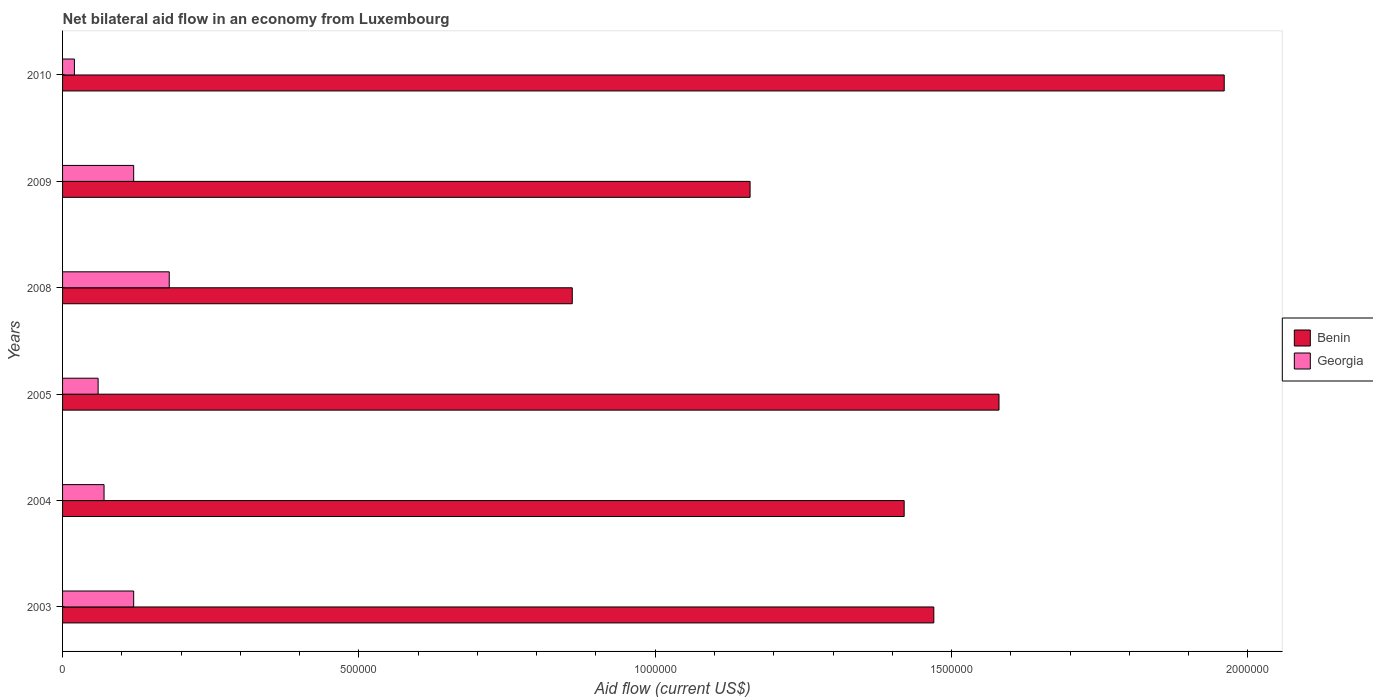Are the number of bars per tick equal to the number of legend labels?
Provide a succinct answer. Yes. How many bars are there on the 6th tick from the top?
Your response must be concise. 2. In how many cases, is the number of bars for a given year not equal to the number of legend labels?
Provide a succinct answer. 0. What is the net bilateral aid flow in Benin in 2009?
Offer a very short reply. 1.16e+06. Across all years, what is the maximum net bilateral aid flow in Benin?
Offer a terse response. 1.96e+06. Across all years, what is the minimum net bilateral aid flow in Georgia?
Ensure brevity in your answer.  2.00e+04. In which year was the net bilateral aid flow in Benin minimum?
Make the answer very short. 2008. What is the total net bilateral aid flow in Benin in the graph?
Ensure brevity in your answer.  8.45e+06. What is the difference between the net bilateral aid flow in Georgia in 2003 and that in 2009?
Give a very brief answer. 0. What is the difference between the net bilateral aid flow in Benin in 2004 and the net bilateral aid flow in Georgia in 2010?
Keep it short and to the point. 1.40e+06. What is the average net bilateral aid flow in Benin per year?
Give a very brief answer. 1.41e+06. In the year 2003, what is the difference between the net bilateral aid flow in Georgia and net bilateral aid flow in Benin?
Keep it short and to the point. -1.35e+06. In how many years, is the net bilateral aid flow in Benin greater than 1400000 US$?
Give a very brief answer. 4. Is the difference between the net bilateral aid flow in Georgia in 2004 and 2009 greater than the difference between the net bilateral aid flow in Benin in 2004 and 2009?
Give a very brief answer. No. What is the difference between the highest and the second highest net bilateral aid flow in Georgia?
Your answer should be compact. 6.00e+04. What is the difference between the highest and the lowest net bilateral aid flow in Georgia?
Offer a terse response. 1.60e+05. In how many years, is the net bilateral aid flow in Benin greater than the average net bilateral aid flow in Benin taken over all years?
Ensure brevity in your answer.  4. What does the 2nd bar from the top in 2009 represents?
Your response must be concise. Benin. What does the 2nd bar from the bottom in 2004 represents?
Your response must be concise. Georgia. How many bars are there?
Offer a terse response. 12. Are all the bars in the graph horizontal?
Make the answer very short. Yes. Does the graph contain any zero values?
Ensure brevity in your answer.  No. How many legend labels are there?
Make the answer very short. 2. How are the legend labels stacked?
Keep it short and to the point. Vertical. What is the title of the graph?
Provide a succinct answer. Net bilateral aid flow in an economy from Luxembourg. Does "Indonesia" appear as one of the legend labels in the graph?
Offer a very short reply. No. What is the label or title of the X-axis?
Your answer should be compact. Aid flow (current US$). What is the Aid flow (current US$) in Benin in 2003?
Ensure brevity in your answer.  1.47e+06. What is the Aid flow (current US$) in Georgia in 2003?
Make the answer very short. 1.20e+05. What is the Aid flow (current US$) of Benin in 2004?
Your response must be concise. 1.42e+06. What is the Aid flow (current US$) in Georgia in 2004?
Provide a succinct answer. 7.00e+04. What is the Aid flow (current US$) of Benin in 2005?
Give a very brief answer. 1.58e+06. What is the Aid flow (current US$) of Benin in 2008?
Provide a succinct answer. 8.60e+05. What is the Aid flow (current US$) in Benin in 2009?
Your response must be concise. 1.16e+06. What is the Aid flow (current US$) in Georgia in 2009?
Offer a very short reply. 1.20e+05. What is the Aid flow (current US$) of Benin in 2010?
Provide a short and direct response. 1.96e+06. What is the Aid flow (current US$) of Georgia in 2010?
Provide a succinct answer. 2.00e+04. Across all years, what is the maximum Aid flow (current US$) of Benin?
Ensure brevity in your answer.  1.96e+06. Across all years, what is the maximum Aid flow (current US$) in Georgia?
Provide a succinct answer. 1.80e+05. Across all years, what is the minimum Aid flow (current US$) of Benin?
Ensure brevity in your answer.  8.60e+05. Across all years, what is the minimum Aid flow (current US$) in Georgia?
Make the answer very short. 2.00e+04. What is the total Aid flow (current US$) in Benin in the graph?
Ensure brevity in your answer.  8.45e+06. What is the total Aid flow (current US$) of Georgia in the graph?
Give a very brief answer. 5.70e+05. What is the difference between the Aid flow (current US$) of Georgia in 2003 and that in 2004?
Your response must be concise. 5.00e+04. What is the difference between the Aid flow (current US$) in Benin in 2003 and that in 2005?
Provide a succinct answer. -1.10e+05. What is the difference between the Aid flow (current US$) in Georgia in 2003 and that in 2008?
Make the answer very short. -6.00e+04. What is the difference between the Aid flow (current US$) in Benin in 2003 and that in 2009?
Your answer should be very brief. 3.10e+05. What is the difference between the Aid flow (current US$) in Georgia in 2003 and that in 2009?
Offer a terse response. 0. What is the difference between the Aid flow (current US$) in Benin in 2003 and that in 2010?
Offer a very short reply. -4.90e+05. What is the difference between the Aid flow (current US$) in Benin in 2004 and that in 2008?
Offer a very short reply. 5.60e+05. What is the difference between the Aid flow (current US$) of Georgia in 2004 and that in 2009?
Make the answer very short. -5.00e+04. What is the difference between the Aid flow (current US$) of Benin in 2004 and that in 2010?
Ensure brevity in your answer.  -5.40e+05. What is the difference between the Aid flow (current US$) in Benin in 2005 and that in 2008?
Your response must be concise. 7.20e+05. What is the difference between the Aid flow (current US$) of Georgia in 2005 and that in 2008?
Offer a very short reply. -1.20e+05. What is the difference between the Aid flow (current US$) in Benin in 2005 and that in 2009?
Keep it short and to the point. 4.20e+05. What is the difference between the Aid flow (current US$) of Georgia in 2005 and that in 2009?
Your answer should be compact. -6.00e+04. What is the difference between the Aid flow (current US$) of Benin in 2005 and that in 2010?
Provide a succinct answer. -3.80e+05. What is the difference between the Aid flow (current US$) of Georgia in 2005 and that in 2010?
Make the answer very short. 4.00e+04. What is the difference between the Aid flow (current US$) of Georgia in 2008 and that in 2009?
Give a very brief answer. 6.00e+04. What is the difference between the Aid flow (current US$) of Benin in 2008 and that in 2010?
Give a very brief answer. -1.10e+06. What is the difference between the Aid flow (current US$) in Benin in 2009 and that in 2010?
Your answer should be very brief. -8.00e+05. What is the difference between the Aid flow (current US$) in Georgia in 2009 and that in 2010?
Your answer should be compact. 1.00e+05. What is the difference between the Aid flow (current US$) of Benin in 2003 and the Aid flow (current US$) of Georgia in 2004?
Give a very brief answer. 1.40e+06. What is the difference between the Aid flow (current US$) in Benin in 2003 and the Aid flow (current US$) in Georgia in 2005?
Ensure brevity in your answer.  1.41e+06. What is the difference between the Aid flow (current US$) in Benin in 2003 and the Aid flow (current US$) in Georgia in 2008?
Offer a very short reply. 1.29e+06. What is the difference between the Aid flow (current US$) in Benin in 2003 and the Aid flow (current US$) in Georgia in 2009?
Your answer should be very brief. 1.35e+06. What is the difference between the Aid flow (current US$) in Benin in 2003 and the Aid flow (current US$) in Georgia in 2010?
Keep it short and to the point. 1.45e+06. What is the difference between the Aid flow (current US$) in Benin in 2004 and the Aid flow (current US$) in Georgia in 2005?
Keep it short and to the point. 1.36e+06. What is the difference between the Aid flow (current US$) in Benin in 2004 and the Aid flow (current US$) in Georgia in 2008?
Provide a short and direct response. 1.24e+06. What is the difference between the Aid flow (current US$) of Benin in 2004 and the Aid flow (current US$) of Georgia in 2009?
Keep it short and to the point. 1.30e+06. What is the difference between the Aid flow (current US$) of Benin in 2004 and the Aid flow (current US$) of Georgia in 2010?
Make the answer very short. 1.40e+06. What is the difference between the Aid flow (current US$) in Benin in 2005 and the Aid flow (current US$) in Georgia in 2008?
Offer a very short reply. 1.40e+06. What is the difference between the Aid flow (current US$) of Benin in 2005 and the Aid flow (current US$) of Georgia in 2009?
Your response must be concise. 1.46e+06. What is the difference between the Aid flow (current US$) of Benin in 2005 and the Aid flow (current US$) of Georgia in 2010?
Give a very brief answer. 1.56e+06. What is the difference between the Aid flow (current US$) in Benin in 2008 and the Aid flow (current US$) in Georgia in 2009?
Provide a short and direct response. 7.40e+05. What is the difference between the Aid flow (current US$) of Benin in 2008 and the Aid flow (current US$) of Georgia in 2010?
Give a very brief answer. 8.40e+05. What is the difference between the Aid flow (current US$) in Benin in 2009 and the Aid flow (current US$) in Georgia in 2010?
Offer a very short reply. 1.14e+06. What is the average Aid flow (current US$) in Benin per year?
Keep it short and to the point. 1.41e+06. What is the average Aid flow (current US$) in Georgia per year?
Give a very brief answer. 9.50e+04. In the year 2003, what is the difference between the Aid flow (current US$) of Benin and Aid flow (current US$) of Georgia?
Make the answer very short. 1.35e+06. In the year 2004, what is the difference between the Aid flow (current US$) in Benin and Aid flow (current US$) in Georgia?
Your response must be concise. 1.35e+06. In the year 2005, what is the difference between the Aid flow (current US$) in Benin and Aid flow (current US$) in Georgia?
Make the answer very short. 1.52e+06. In the year 2008, what is the difference between the Aid flow (current US$) in Benin and Aid flow (current US$) in Georgia?
Offer a terse response. 6.80e+05. In the year 2009, what is the difference between the Aid flow (current US$) in Benin and Aid flow (current US$) in Georgia?
Your answer should be compact. 1.04e+06. In the year 2010, what is the difference between the Aid flow (current US$) of Benin and Aid flow (current US$) of Georgia?
Provide a succinct answer. 1.94e+06. What is the ratio of the Aid flow (current US$) in Benin in 2003 to that in 2004?
Keep it short and to the point. 1.04. What is the ratio of the Aid flow (current US$) in Georgia in 2003 to that in 2004?
Provide a succinct answer. 1.71. What is the ratio of the Aid flow (current US$) of Benin in 2003 to that in 2005?
Provide a succinct answer. 0.93. What is the ratio of the Aid flow (current US$) of Georgia in 2003 to that in 2005?
Give a very brief answer. 2. What is the ratio of the Aid flow (current US$) in Benin in 2003 to that in 2008?
Offer a very short reply. 1.71. What is the ratio of the Aid flow (current US$) of Benin in 2003 to that in 2009?
Make the answer very short. 1.27. What is the ratio of the Aid flow (current US$) in Benin in 2003 to that in 2010?
Offer a terse response. 0.75. What is the ratio of the Aid flow (current US$) in Georgia in 2003 to that in 2010?
Offer a terse response. 6. What is the ratio of the Aid flow (current US$) of Benin in 2004 to that in 2005?
Keep it short and to the point. 0.9. What is the ratio of the Aid flow (current US$) in Benin in 2004 to that in 2008?
Offer a very short reply. 1.65. What is the ratio of the Aid flow (current US$) of Georgia in 2004 to that in 2008?
Ensure brevity in your answer.  0.39. What is the ratio of the Aid flow (current US$) of Benin in 2004 to that in 2009?
Your answer should be compact. 1.22. What is the ratio of the Aid flow (current US$) in Georgia in 2004 to that in 2009?
Offer a very short reply. 0.58. What is the ratio of the Aid flow (current US$) of Benin in 2004 to that in 2010?
Provide a succinct answer. 0.72. What is the ratio of the Aid flow (current US$) in Benin in 2005 to that in 2008?
Offer a very short reply. 1.84. What is the ratio of the Aid flow (current US$) in Georgia in 2005 to that in 2008?
Provide a short and direct response. 0.33. What is the ratio of the Aid flow (current US$) in Benin in 2005 to that in 2009?
Your response must be concise. 1.36. What is the ratio of the Aid flow (current US$) in Benin in 2005 to that in 2010?
Your response must be concise. 0.81. What is the ratio of the Aid flow (current US$) in Georgia in 2005 to that in 2010?
Keep it short and to the point. 3. What is the ratio of the Aid flow (current US$) in Benin in 2008 to that in 2009?
Ensure brevity in your answer.  0.74. What is the ratio of the Aid flow (current US$) in Georgia in 2008 to that in 2009?
Offer a very short reply. 1.5. What is the ratio of the Aid flow (current US$) of Benin in 2008 to that in 2010?
Your response must be concise. 0.44. What is the ratio of the Aid flow (current US$) of Georgia in 2008 to that in 2010?
Offer a very short reply. 9. What is the ratio of the Aid flow (current US$) of Benin in 2009 to that in 2010?
Provide a succinct answer. 0.59. What is the ratio of the Aid flow (current US$) in Georgia in 2009 to that in 2010?
Keep it short and to the point. 6. What is the difference between the highest and the second highest Aid flow (current US$) in Benin?
Your response must be concise. 3.80e+05. What is the difference between the highest and the second highest Aid flow (current US$) of Georgia?
Your answer should be compact. 6.00e+04. What is the difference between the highest and the lowest Aid flow (current US$) in Benin?
Give a very brief answer. 1.10e+06. 